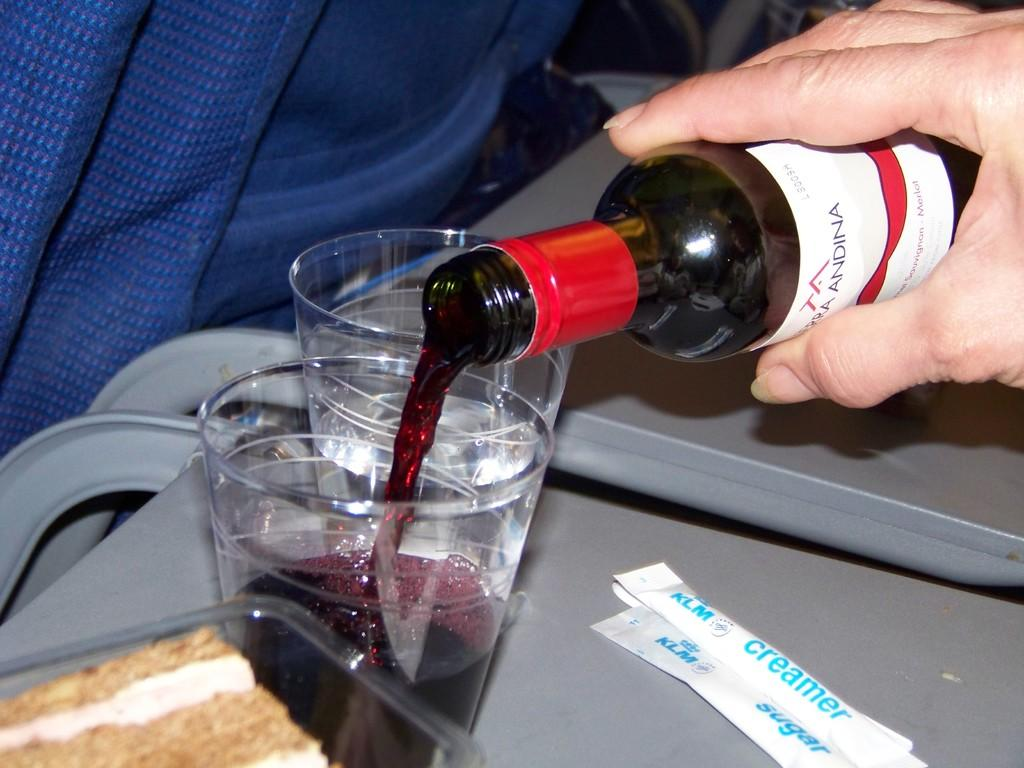<image>
Describe the image concisely. hand pouring liquid from a bottle into a cup and pakcets of klm creamer and klm sugar next to cup 